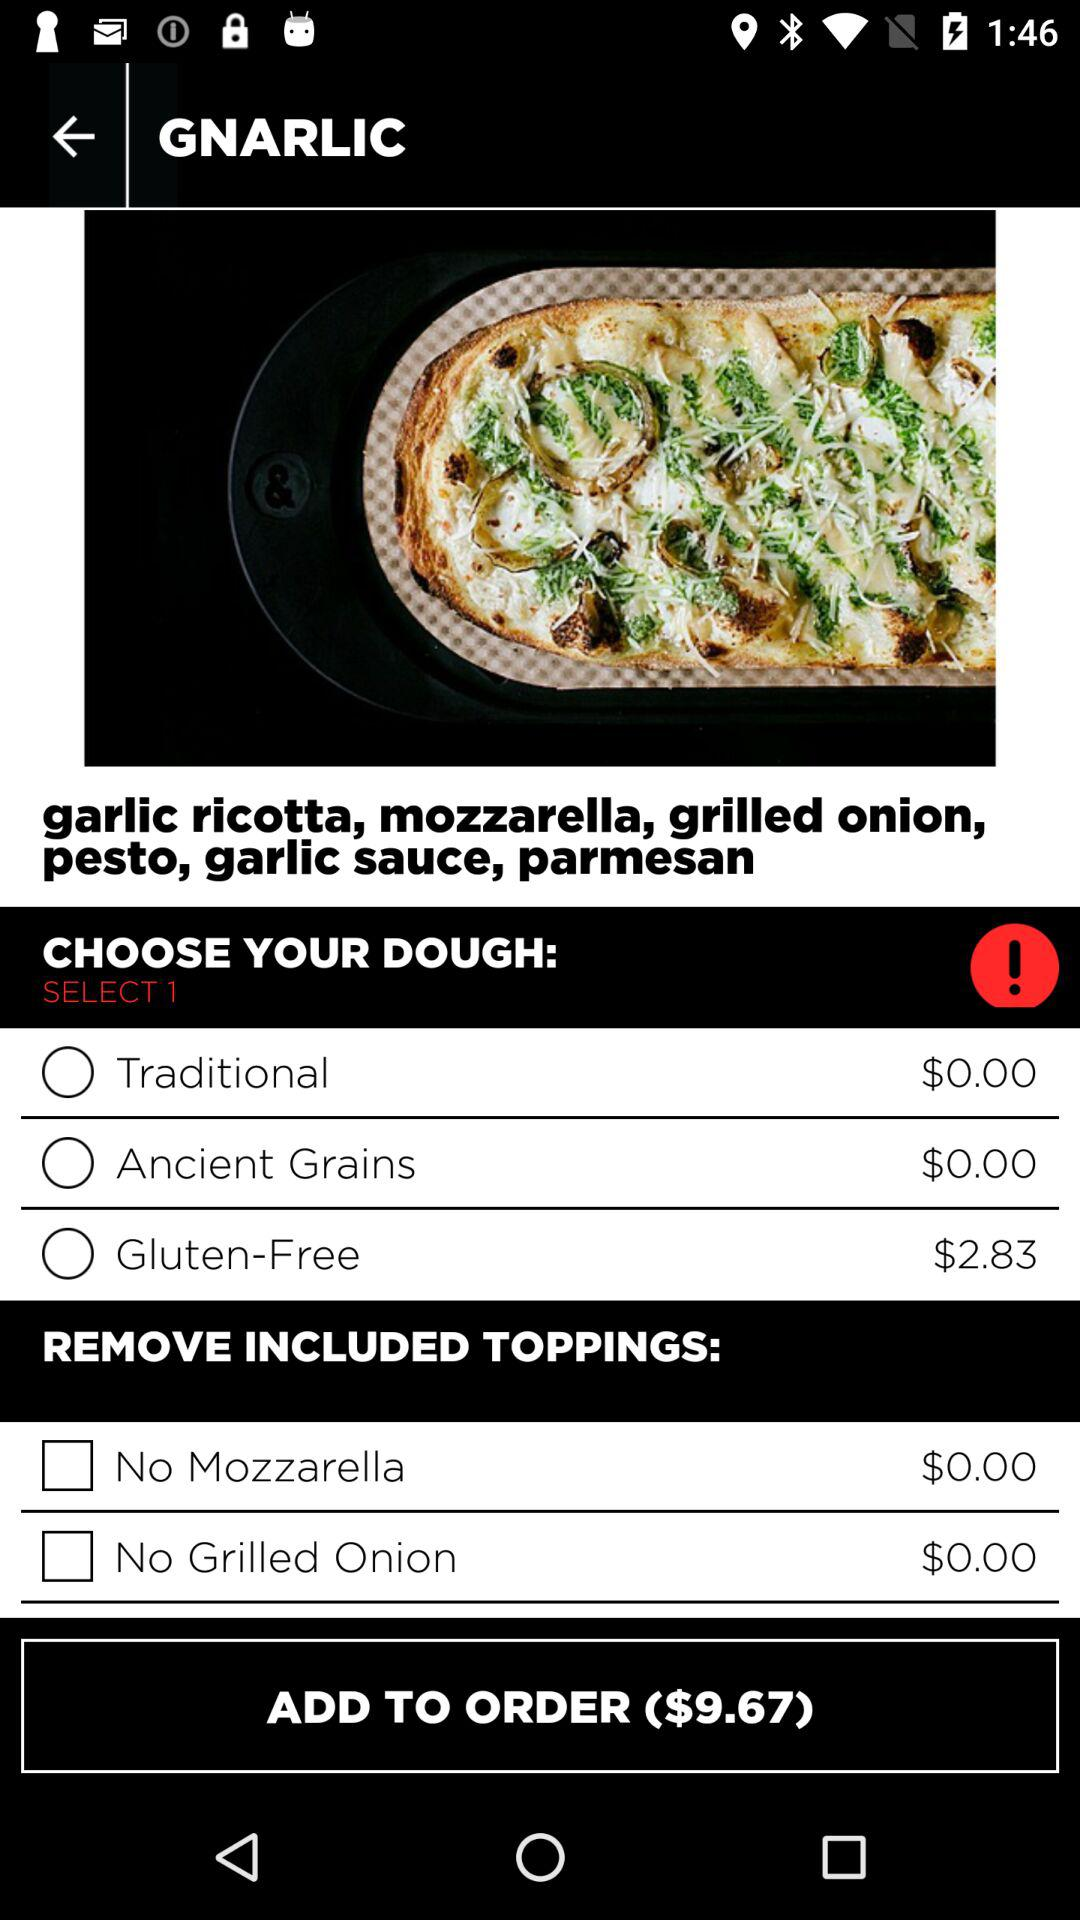What is the price of traditional dough? The price is $0. 